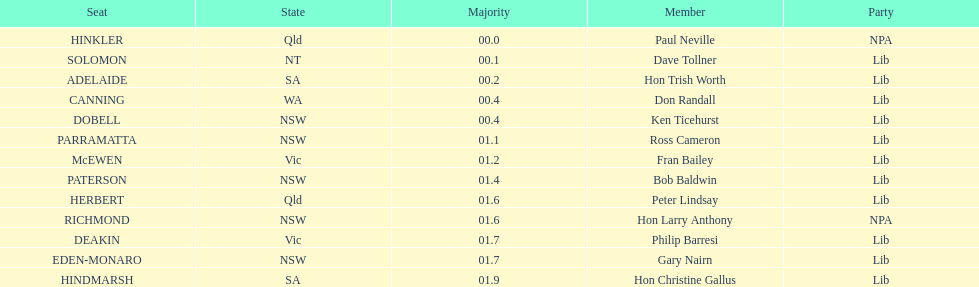What party had the most seats? Lib. 